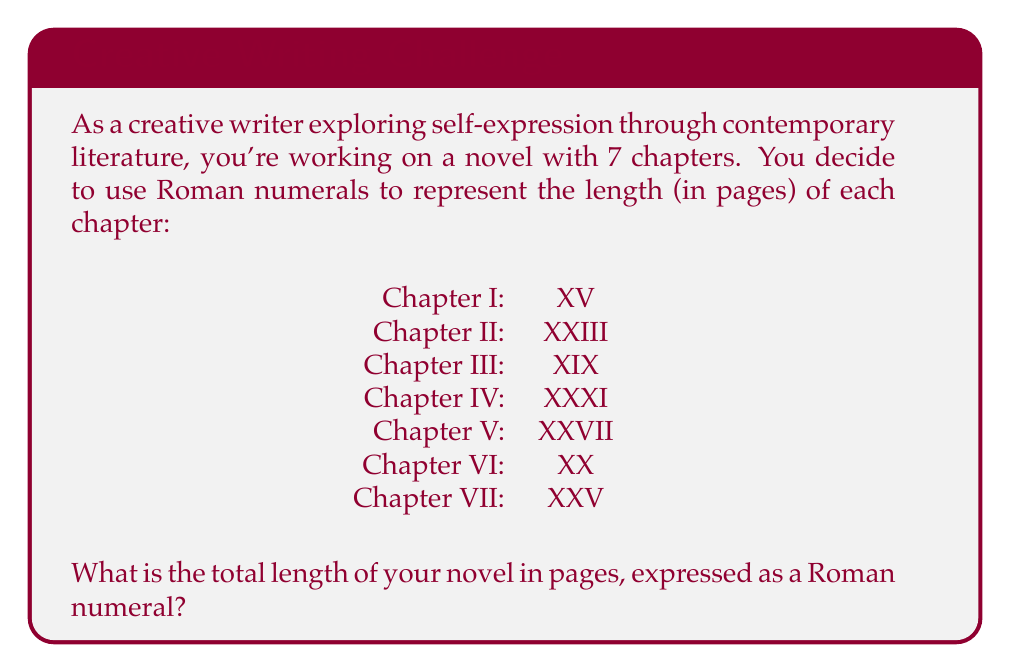Can you solve this math problem? To solve this problem, we need to follow these steps:

1. Convert each Roman numeral to its decimal equivalent:
   I: XV = 15
   II: XXIII = 23
   III: XIX = 19
   IV: XXXI = 31
   V: XXVII = 27
   VI: XX = 20
   VII: XXV = 25

2. Sum up all the decimal values:
   $15 + 23 + 19 + 31 + 27 + 20 + 25 = 160$

3. Convert the sum (160) back to Roman numerals:
   - 100 = C
   - 50 = L
   - 10 = X

   So, 160 in Roman numerals is CLX

Therefore, the total length of the novel is CLX pages in Roman numerals.
Answer: CLX 